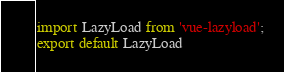<code> <loc_0><loc_0><loc_500><loc_500><_JavaScript_>import LazyLoad from 'vue-lazyload';
export default LazyLoad</code> 